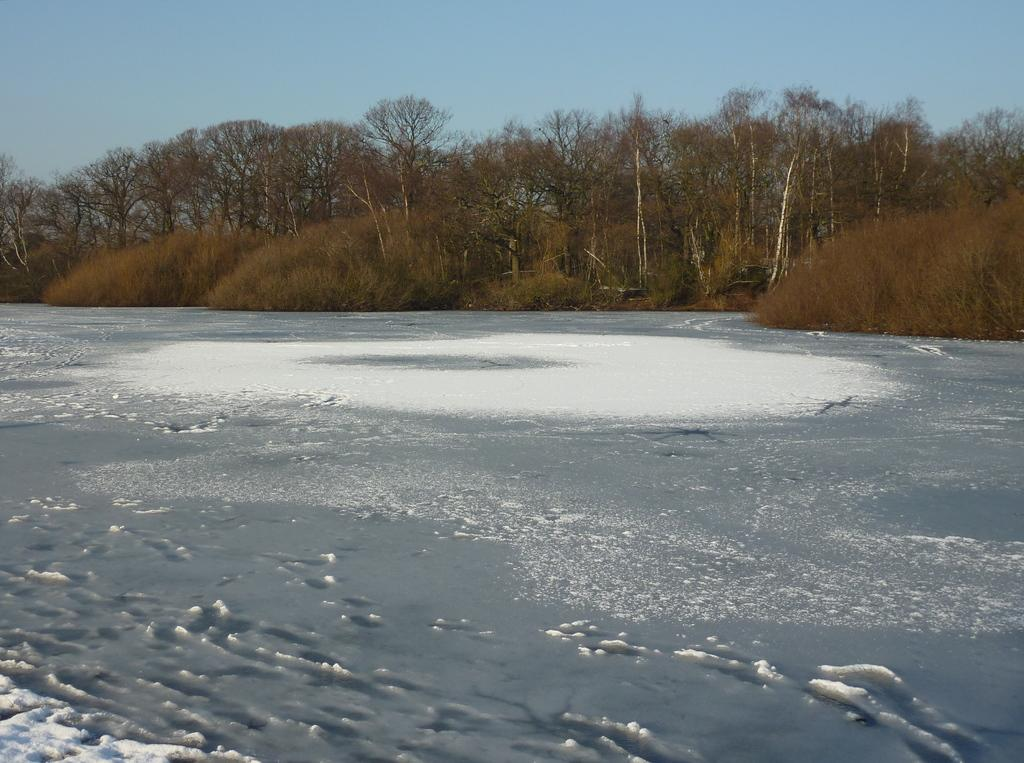What can be seen in the sky in the image? The sky is visible in the image, but no specific details about the sky are mentioned. What type of vegetation is present in the image? There are trees in the image. What natural feature is depicted in the image? There is an iceberg in the image. Can you tell me how many achievers are visible in the image? There is no mention of achievers in the image, so it is not possible to answer that question. 